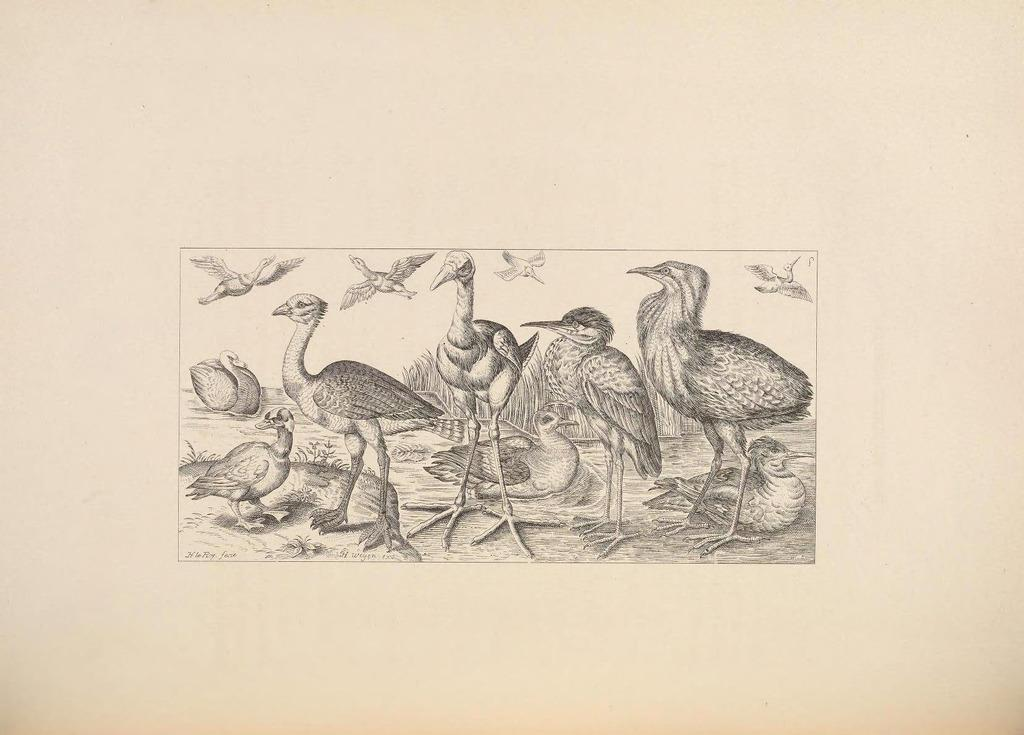What is the main subject of the image? There is a drawing in the image. What type of animals are depicted in the drawing? The drawing contains birds. How much money is being exchanged between the birds in the image? There is no money present in the image, as it is a drawing of birds. 